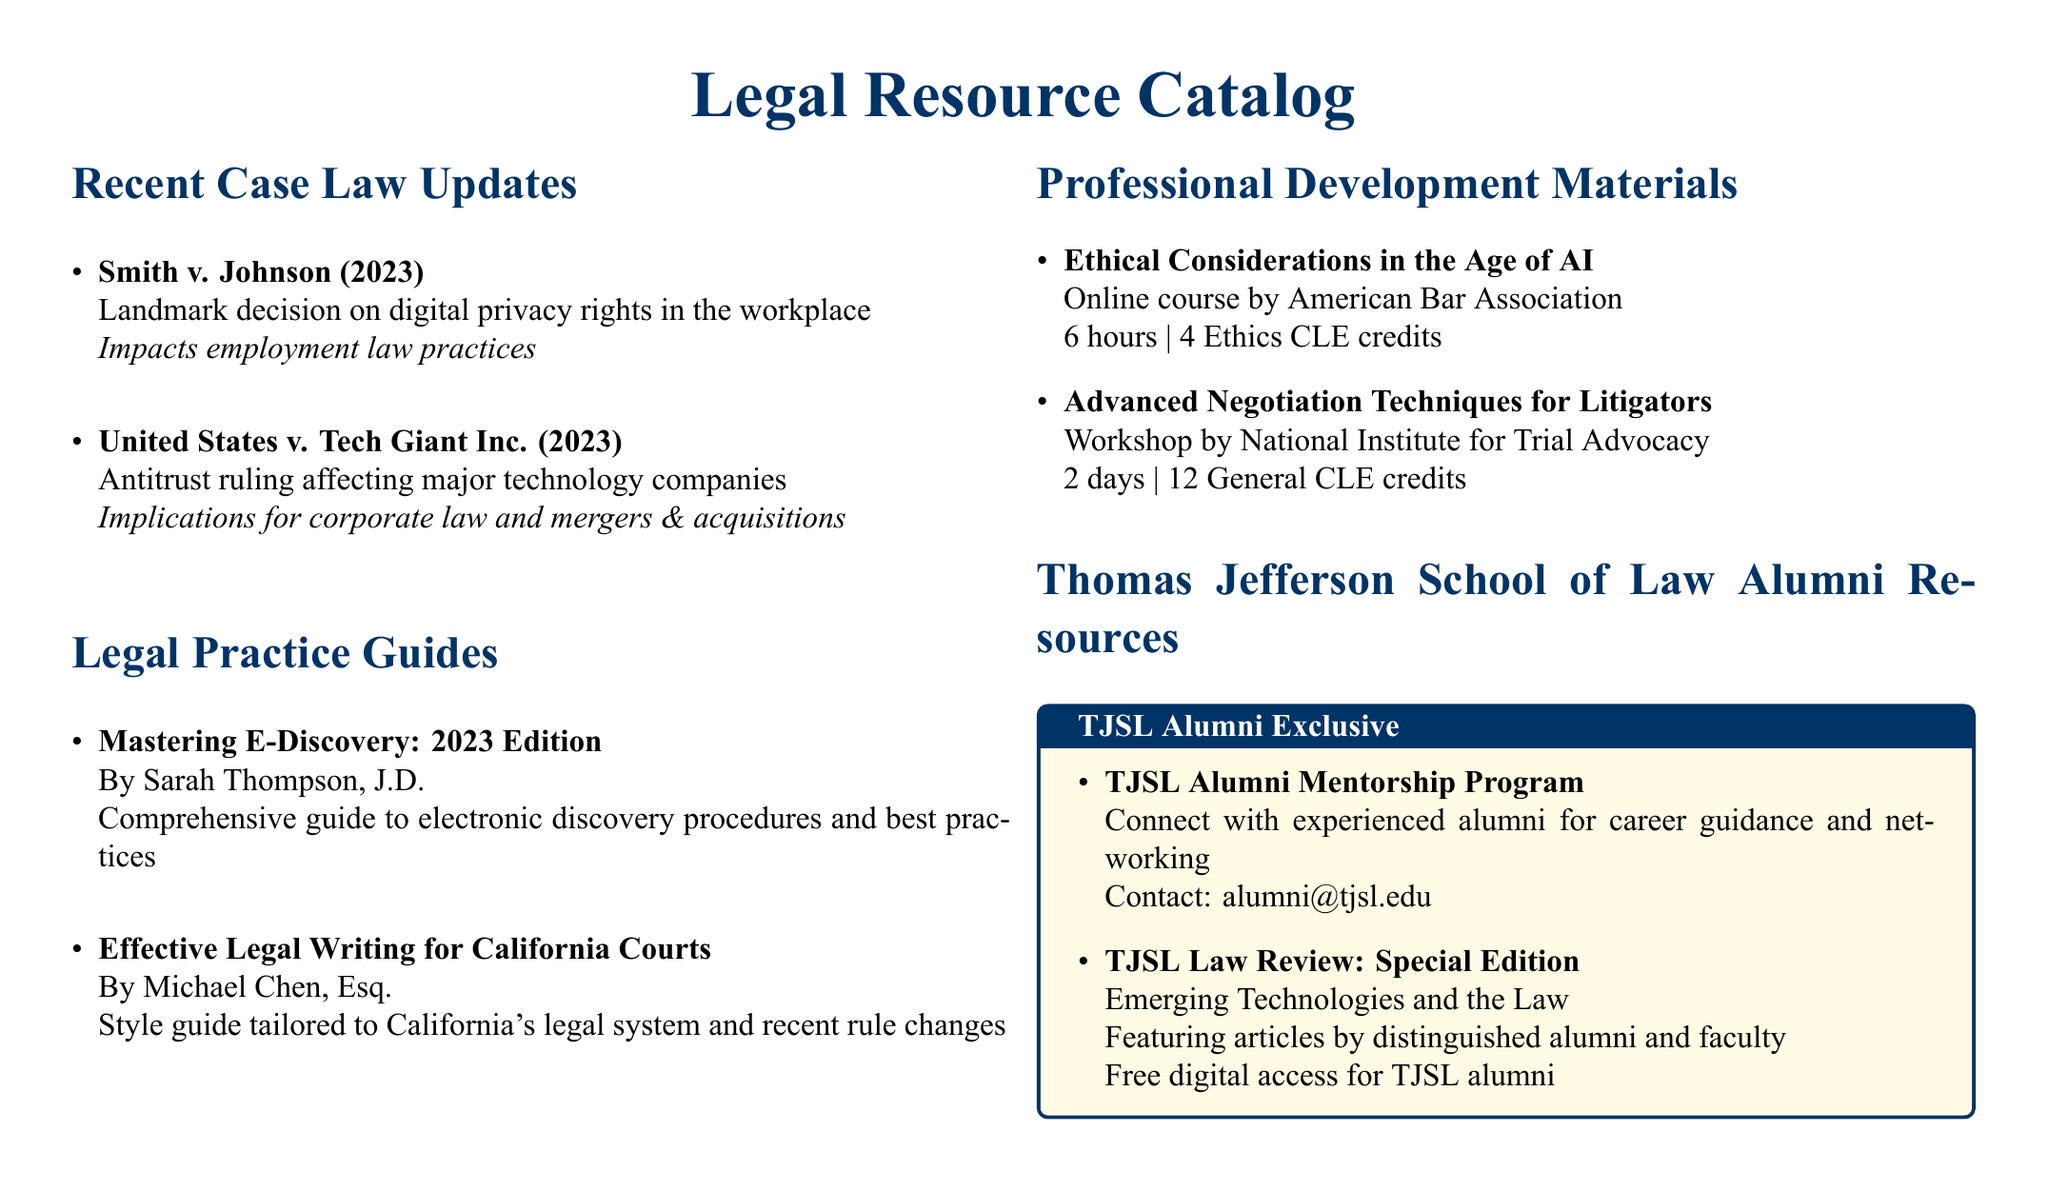What is a recent case related to digital privacy rights? The document lists a case, "Smith v. Johnson," which addresses digital privacy rights in the workplace.
Answer: Smith v. Johnson Who authored the guide on effective legal writing for California Courts? The author of the guide titled "Effective Legal Writing for California Courts" is Michael Chen, Esq.
Answer: Michael Chen, Esq How many General CLE credits are awarded for the Advanced Negotiation Techniques workshop? The workshop provides 12 General CLE credits as mentioned in the document.
Answer: 12 Which program connects TJSL alumni with experienced mentors? The document highlights the "TJSL Alumni Mentorship Program" as a resource for connecting with mentors.
Answer: TJSL Alumni Mentorship Program What year was the Mastering E-Discovery guide published? The guide titled "Mastering E-Discovery" is specified to be the 2023 Edition.
Answer: 2023 What is the main focus of the online course offered by the American Bar Association? The course titled "Ethical Considerations in the Age of AI" is focused on ethics in relation to artificial intelligence.
Answer: Ethics in AI What specific legal area does the case "United States v. Tech Giant Inc." pertain to? The document states that this case pertains to antitrust issues affecting major technology companies.
Answer: Antitrust Which publication features articles by distinguished alumni and faculty? The "TJSL Law Review: Special Edition" focuses on emerging technologies and the law and features contributions from alumni and faculty.
Answer: TJSL Law Review: Special Edition 